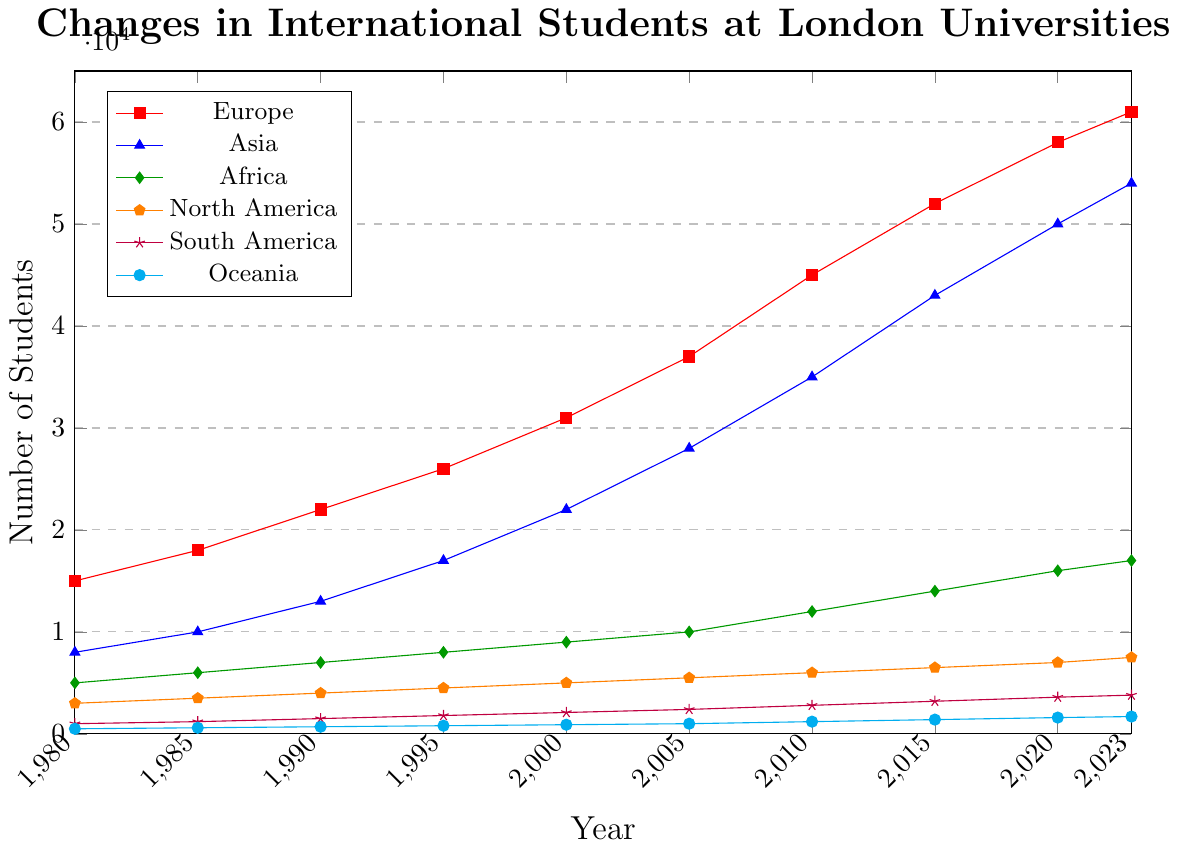What continent saw the greatest increase in the number of international students from 1980 to 2023? To determine which continent saw the greatest increase, we look at the difference between the number of students in 2023 and 1980 for each continent. For Europe, the increase is 61000 - 15000 = 46000. For Asia, it is 54000 - 8000 = 46000. For Africa, it is 17000 - 5000 = 12000. For North America, it is 7500 - 3000 = 4500. For South America, it is 3800 - 1000 = 2800. For Oceania, it is 1700 - 500 = 1200. Asia and Europe both saw the greatest increase of 46000 students.
Answer: Asia and Europe Between which years did Asia see the most significant increase in the number of international students? We compare the differences between consecutive years for the values in Asia. The differences are: (1985-1980) = 2000, (1990-1985) = 3000, (1995-1990) = 4000, (2000-1995) = 5000, (2005-2000) = 6000, (2010-2005) = 7000, (2015-2010) = 8000, (2020-2015) = 7000, (2023-2020) = 4000. The most significant increase is between 2010 and 2015, which is 8000.
Answer: 2010 and 2015 In what year did the number of international students from Europe first exceed 30,000? By looking at the trend for Europe, we see that the number first exceeds 30,000 in the year 2000 where it is 31,000.
Answer: 2000 Which continent had the smallest number of international students throughout the entire period from 1980 to 2023? We need to look at the values for each year for all the continents and find the minimum number in each series. The smallest numbers are for Europe (15000), Asia (8000), Africa (5000), North America (3000), South America (1000), and Oceania (500). Oceania consistently has the smallest number of students.
Answer: Oceania How many more students were there from Africa in 2023 compared to North America in the same year? To find the number of more students from Africa compared to North America in 2023, subtract the North America value from the Africa value in 2023: 17000 - 7500 = 9500.
Answer: 9500 